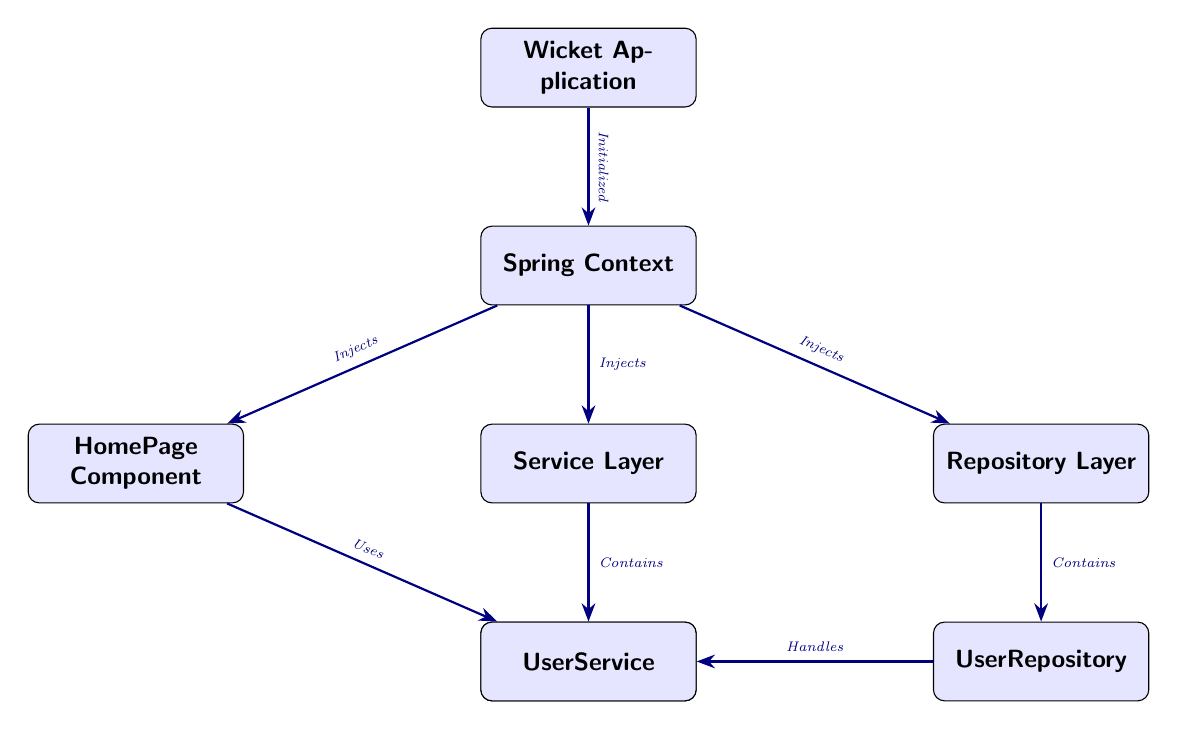What is the top node in the diagram? The top node is labeled as the "Wicket Application." It is the first node at the highest position in the diagram, indicating the main application context.
Answer: Wicket Application How many components are directly injected by the Spring Context? The Spring Context node has three arrows pointing towards it, indicating it injects three components: HomePage Component, Service Layer, and Repository Layer.
Answer: Three Which component uses the UserService? The HomePage Component node has an arrow pointing towards the UserService node, indicating that it uses the UserService.
Answer: HomePage Component What is the relationship between the Service Layer and UserService? The Service Layer node contains the UserService, as indicated by the arrow pointing from the Service Layer to the UserService with a label "Contains."
Answer: Contains Which layer handles the User Entity? The UserRepository node has an arrow pointing towards the User Entity, labeled "Handles," indicating it is responsible for handling the User Entity.
Answer: UserRepository Which two components are parallel to the Service Layer in the diagram? The Repository Layer is at the same level, below the Spring Context and the HomePage Component is also at a similar level, demonstrating parallel placement with respect to the Service Layer.
Answer: HomePage Component and Repository Layer What is the lowest level component in the diagram? The User Entity is situated at the lowest position in the diagram, below both the UserRepository and Repository Layer, indicating it is the base component.
Answer: User Entity How many total nodes are present in the diagram? By counting each labeled box in the diagram, there are seven distinct nodes in total, encompassing all components and layers depicted.
Answer: Seven What signifies the flow of information from the Wicket Application to the Spring Context? The arrow labeled "Initialized" signifies that the Wicket Application initializes the Spring Context, indicating a directional flow of control or information.
Answer: Initialized Which layer directly contains the UserRepository? The Repository Layer contains the UserRepository, as indicated by the arrow labeled "Contains" that directly points from the Repository Layer to the UserRepository.
Answer: Repository Layer 